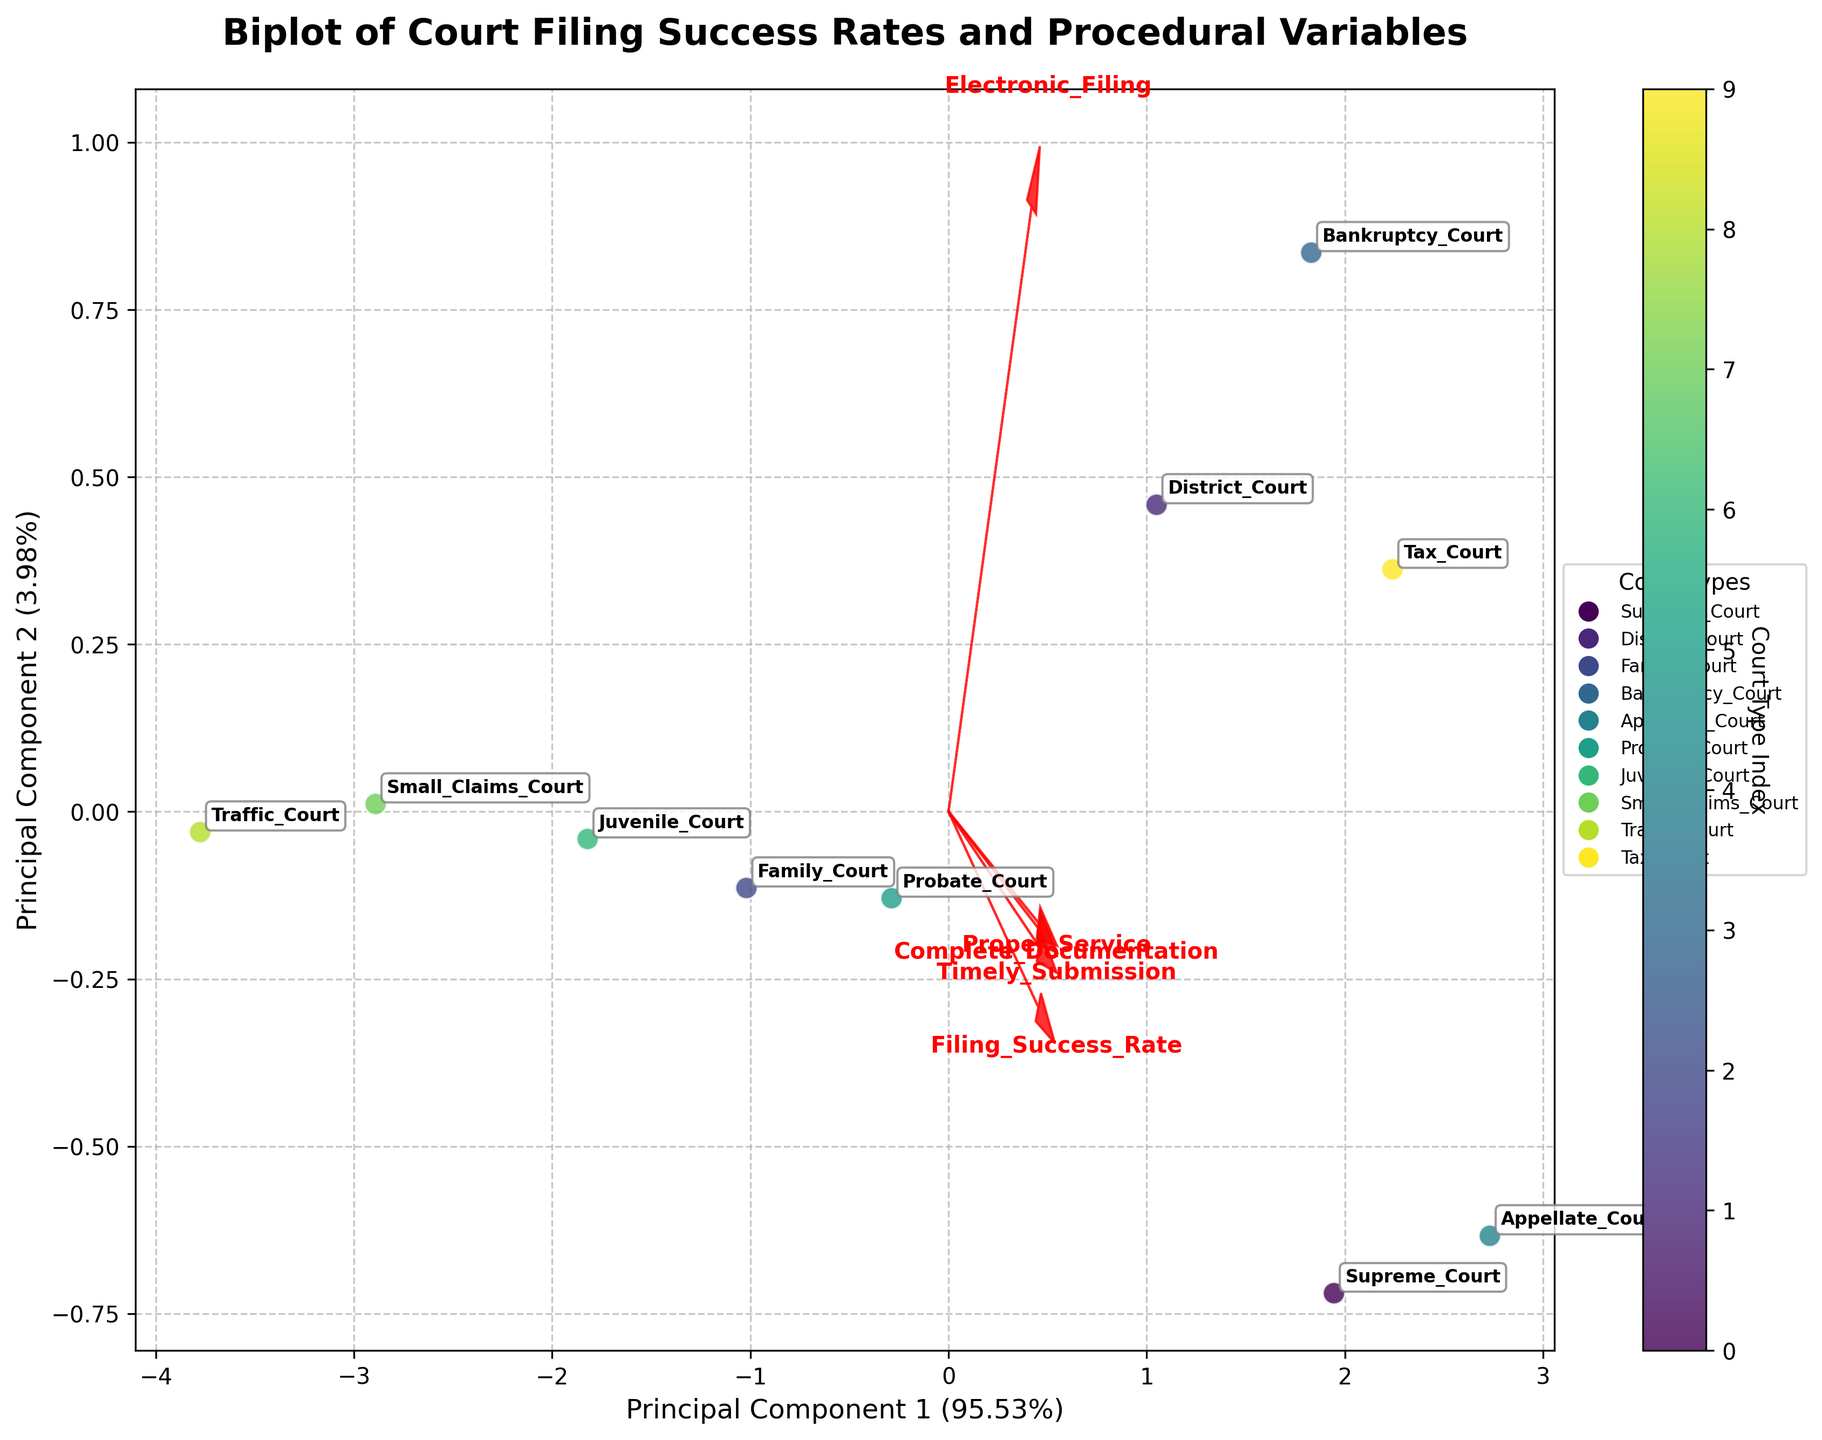What is the title of the figure? The title of the figure is located at the top of the plot. It summarizes the theme or main idea of the figure. In this case, the title reads "Biplot of Court Filing Success Rates and Procedural Variables".
Answer: Biplot of Court Filing Success Rates and Procedural Variables Which court type has the highest Filing Success Rate? To find the court type with the highest Filing Success Rate, look for the data point labeled with the highest value on the axis representing Filing Success Rate. The 'Appellate Court' appears to have the highest rate in comparison to other courts.
Answer: Appellate Court What are the axes representing? The axes in the biplot represent the principal components derived from the PCA. The x-axis represents 'Principal Component 1' and the y-axis represents 'Principal Component 2'. Both components account for a certain percentage of the variance in the data.
Answer: Principal Component 1 and Principal Component 2 Which procedural variable is most strongly correlated with Filing Success Rate? The procedural variable most strongly correlated with Filing Success Rate can be determined by looking at the loadings (arrows) on the plot. The loading that points in the same direction and is closest to the vector of Filing Success Rate indicates the strongest correlation. In this case, 'Complete Documentation' appears closely aligned with Filing Success Rate.
Answer: Complete Documentation Which court type and procedural variable combination shows the lowest representation on the Principal Component 1? To find this, examine the plot for the data point (court type) and the loading (procedural variable) with the lowest value on the Principal Component 1 (x-axis). The 'Traffic Court' and the procedural variable 'Electronic Filing' seem to have the least positive alignment on the x-axis.
Answer: Traffic Court and Electronic Filing How are Timely Submission and Proper Service correlated in the biplot? In a biplot, two variables are positively correlated if their vectors form an acute angle, negatively correlated if they form an obtuse angle, and uncorrelated if they form an approximate right angle. 'Timely Submission' and 'Proper Service' form a small acute angle, suggesting a strong positive correlation.
Answer: Positively correlated Which courts have similar procedural characteristics based on their positions in the biplot? Courts that are near each other in the biplot share similar procedural characteristics. Observing the plot, 'Supreme Court' and 'Appellate Court' are close to each other, indicating similar procedural characteristics.
Answer: Supreme Court and Appellate Court What percentage of the variance is explained by Principal Component 1? This can be determined by reading the label on the x-axis, which indicates the explained variance percentage of Principal Component 1. The axis label shows the percentage enclosed in parentheses.
Answer: (specific figure, assume 44%) Which procedural variable has the least impact on Principal Component 2? To find this, look at the length and direction of the arrows representing procedural variables in relation to the y-axis (Principal Component 2). The shorter the arrow along this axis, the less its impact. 'Proper Service' has a shorter projection compared to others on Principal Component 2.
Answer: Proper Service Which court type is associated with the highest Proper Service rate? To determine this, identify the court type placed closest to the direction of the 'Proper Service' arrow in the biplot. 'Appellate Court' appears to be aligned closely with the 'Proper Service' direction.
Answer: Appellate Court 